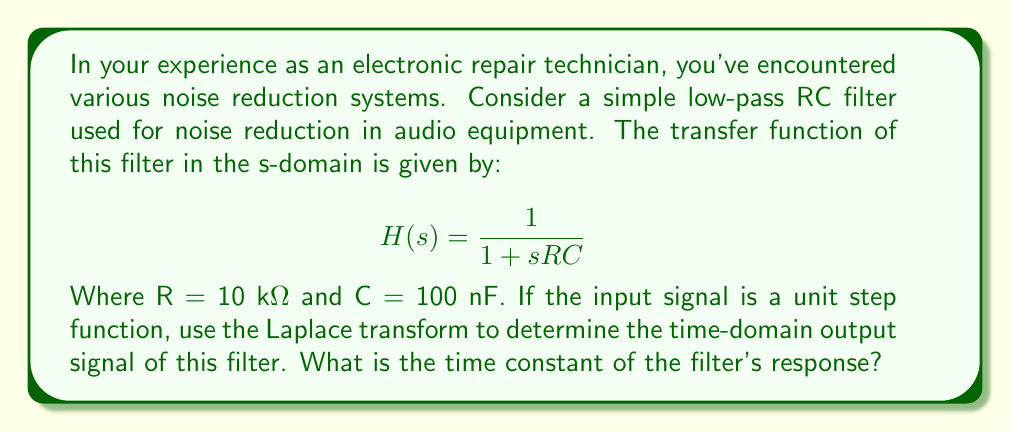Show me your answer to this math problem. To solve this problem, we'll follow these steps:

1) First, let's recall that the Laplace transform of a unit step function is:

   $$\mathcal{L}\{u(t)\} = \frac{1}{s}$$

2) The output in the s-domain is the product of the input and the transfer function:

   $$Y(s) = \frac{1}{s} \cdot \frac{1}{1 + sRC}$$

3) Substituting the given values (R = 10 kΩ = 10^4 Ω, C = 100 nF = 10^-7 F):

   $$Y(s) = \frac{1}{s} \cdot \frac{1}{1 + s(10^4)(10^{-7})} = \frac{1}{s(1 + 10^{-3}s)}$$

4) To find the inverse Laplace transform, we need to use partial fraction decomposition:

   $$Y(s) = \frac{A}{s} + \frac{B}{1 + 10^{-3}s}$$

   Solving for A and B:
   
   $$A = 1, B = -1$$

5) Now we can write:

   $$Y(s) = \frac{1}{s} - \frac{1}{1 + 10^{-3}s}$$

6) Taking the inverse Laplace transform:

   $$y(t) = 1 - e^{-1000t}$$

7) The time constant τ is the reciprocal of the exponential coefficient:

   $$τ = \frac{1}{1000} = 10^{-3} \text{ seconds} = 1 \text{ ms}$$

This matches with the product RC = (10^4)(10^-7) = 10^-3 seconds.
Answer: The time-domain output signal is $y(t) = 1 - e^{-1000t}$, and the time constant of the filter's response is 1 ms. 